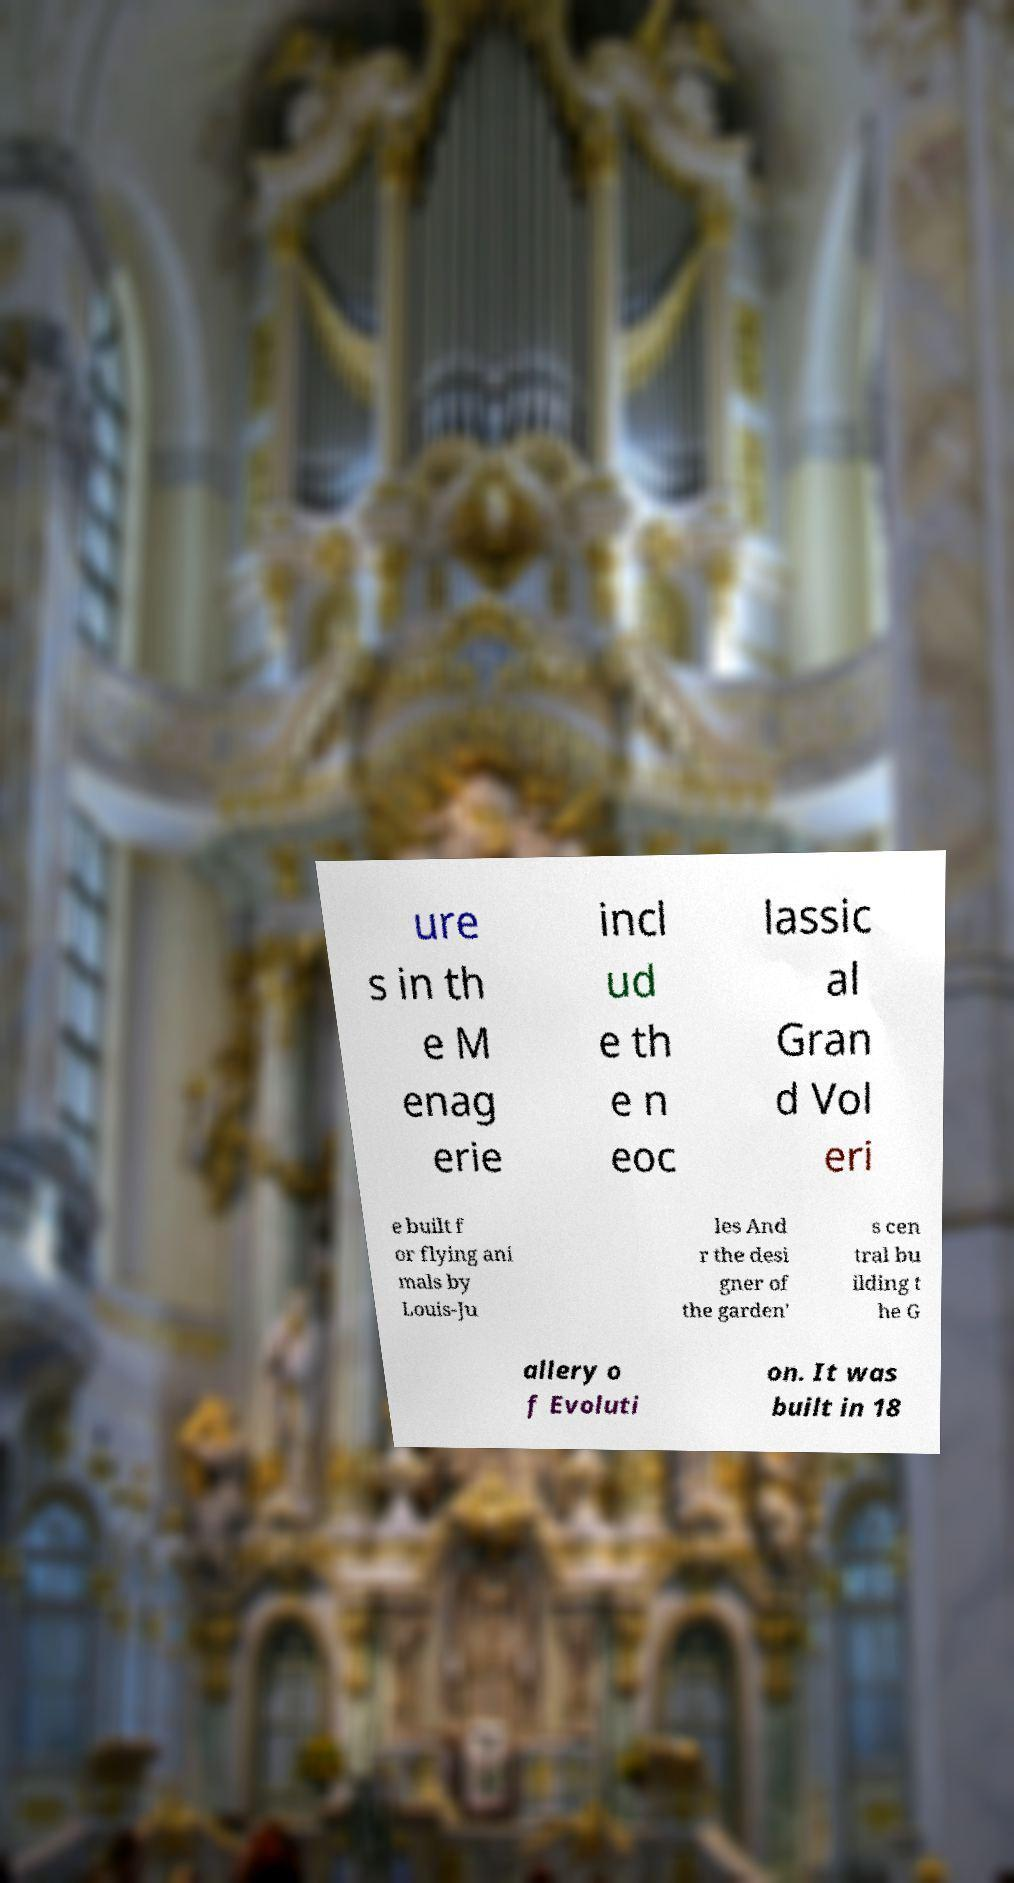Can you accurately transcribe the text from the provided image for me? ure s in th e M enag erie incl ud e th e n eoc lassic al Gran d Vol eri e built f or flying ani mals by Louis-Ju les And r the desi gner of the garden' s cen tral bu ilding t he G allery o f Evoluti on. It was built in 18 